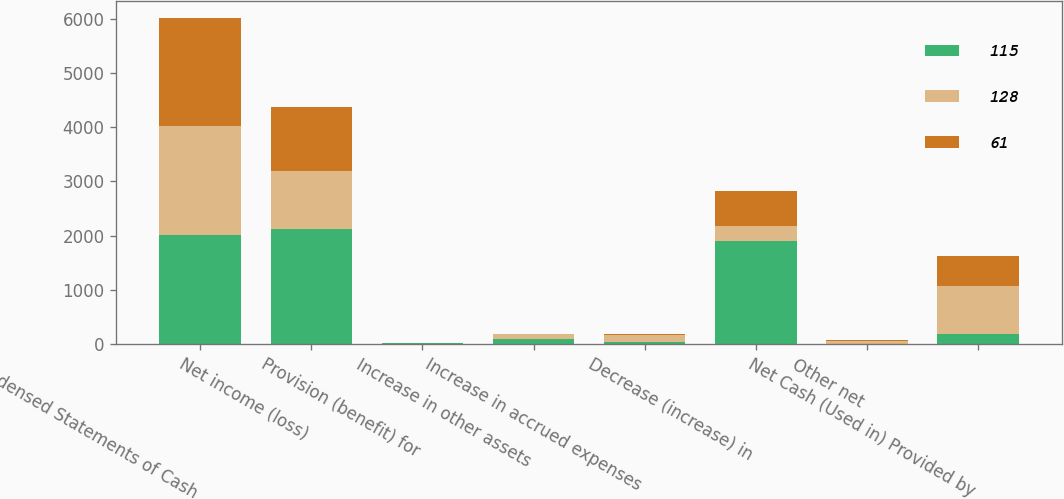Convert chart to OTSL. <chart><loc_0><loc_0><loc_500><loc_500><stacked_bar_chart><ecel><fcel>Condensed Statements of Cash<fcel>Net income (loss)<fcel>Provision (benefit) for<fcel>Increase in other assets<fcel>Increase in accrued expenses<fcel>Decrease (increase) in<fcel>Other net<fcel>Net Cash (Used in) Provided by<nl><fcel>115<fcel>2008<fcel>2113<fcel>11<fcel>85<fcel>40<fcel>1903<fcel>5<fcel>192<nl><fcel>128<fcel>2007<fcel>1076<fcel>7<fcel>98<fcel>132<fcel>276<fcel>46<fcel>873<nl><fcel>61<fcel>2006<fcel>1188<fcel>1<fcel>1<fcel>17<fcel>642<fcel>14<fcel>549<nl></chart> 